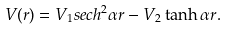Convert formula to latex. <formula><loc_0><loc_0><loc_500><loc_500>V ( r ) = V _ { 1 } s e c h ^ { 2 } { \alpha r } - V _ { 2 } \tanh { \alpha r } .</formula> 